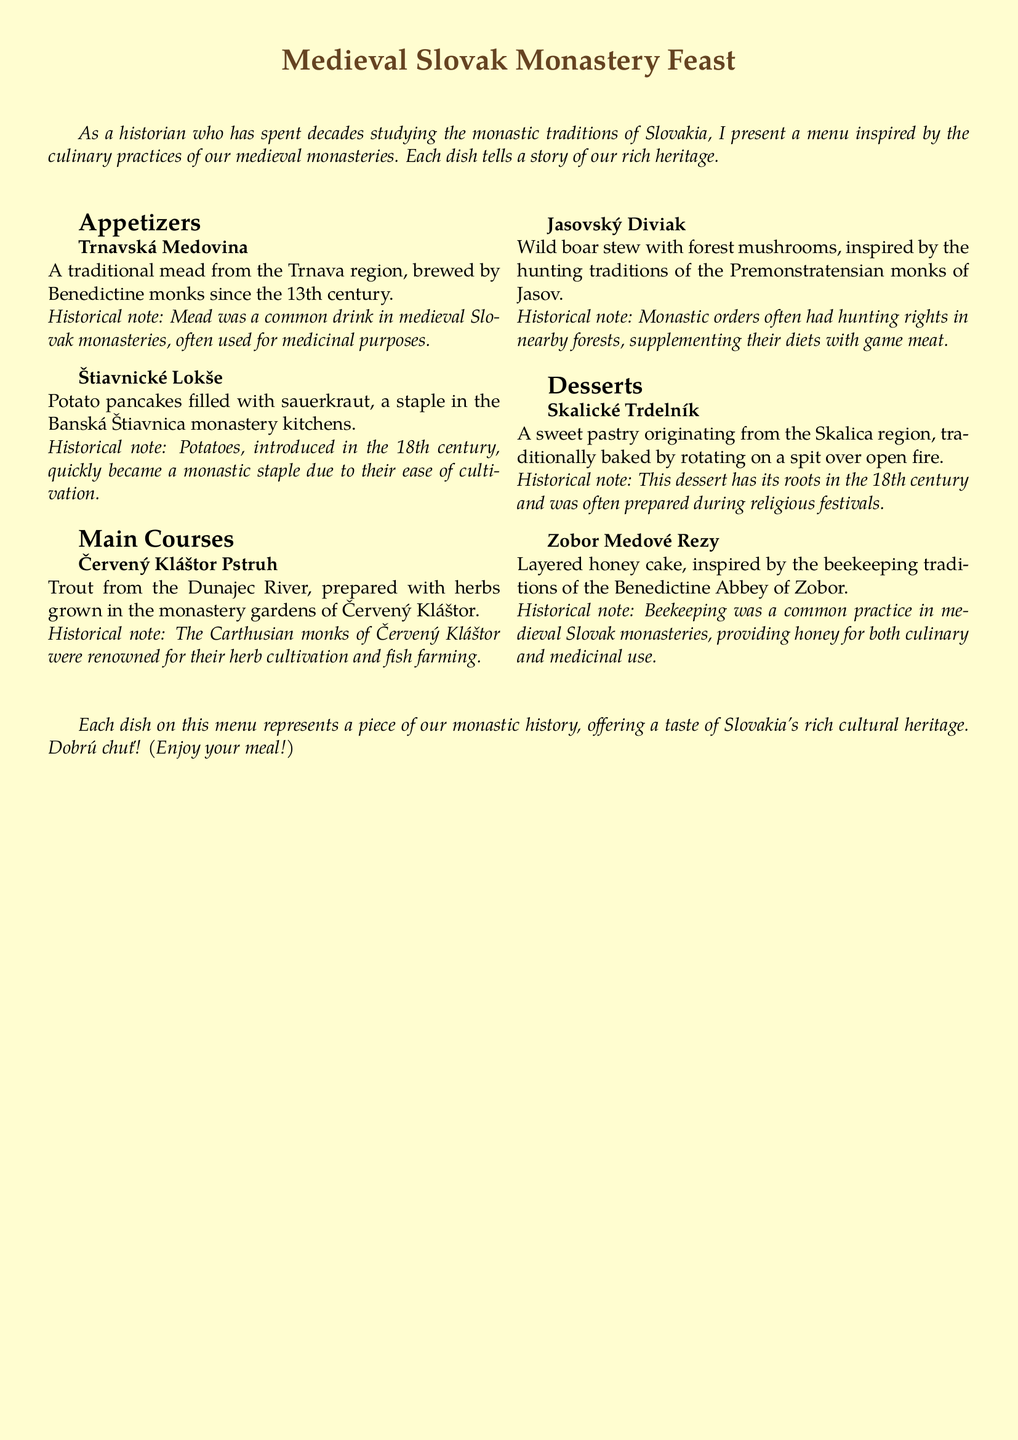What beverage is mentioned as a traditional drink? The document states that Trnavská Medovina is a traditional mead from the Trnava region brewed by Benedictine monks since the 13th century.
Answer: Trnavská Medovina Which medieval monastic order is associated with trout dishes? The Červený Kláštor Pstruh dish is linked to the Carthusian monks of Červený Kláštor, who were known for their herb cultivation and fish farming.
Answer: Carthusian monks What two main ingredients are featured in Štiavnické Lokše? Štiavnické Lokše are potato pancakes filled with sauerkraut, highlighting these as staple ingredients in the Banská Štiavnica monastery kitchens.
Answer: Potatoes and sauerkraut In what century did beekeeping become prominent in the Benedictine Abbey of Zobor? The Zobor Medové Rezy dessert is inspired by beekeeping traditions of the Benedictine Abbey of Zobor, indicating that such practices were common in medieval times.
Answer: Medieval times What method is used to prepare Skalické Trdelník? The document describes Skalické Trdelník as being traditionally baked by rotating on a spit over open fire, emphasizing this cooking technique.
Answer: Rotating on a spit over open fire What is the historical significance of mead according to the menu? The historical note mentions that mead was a common drink in medieval Slovak monasteries, often used for medicinal purposes, showcasing its importance.
Answer: Medicinal purposes Which two dishes include wild game as an ingredient? The main courses Jasovský Diviak and its wild boar stew demonstrate the incorporation of game meat in monastic diets, linked to hunting rights held by monks.
Answer: Jasovský Diviak What is a characteristic of potato cultivation mentioned in the document? The document states that potatoes quickly became a monastic staple due to their ease of cultivation, highlighting their practicality in monastery kitchens.
Answer: Ease of cultivation 